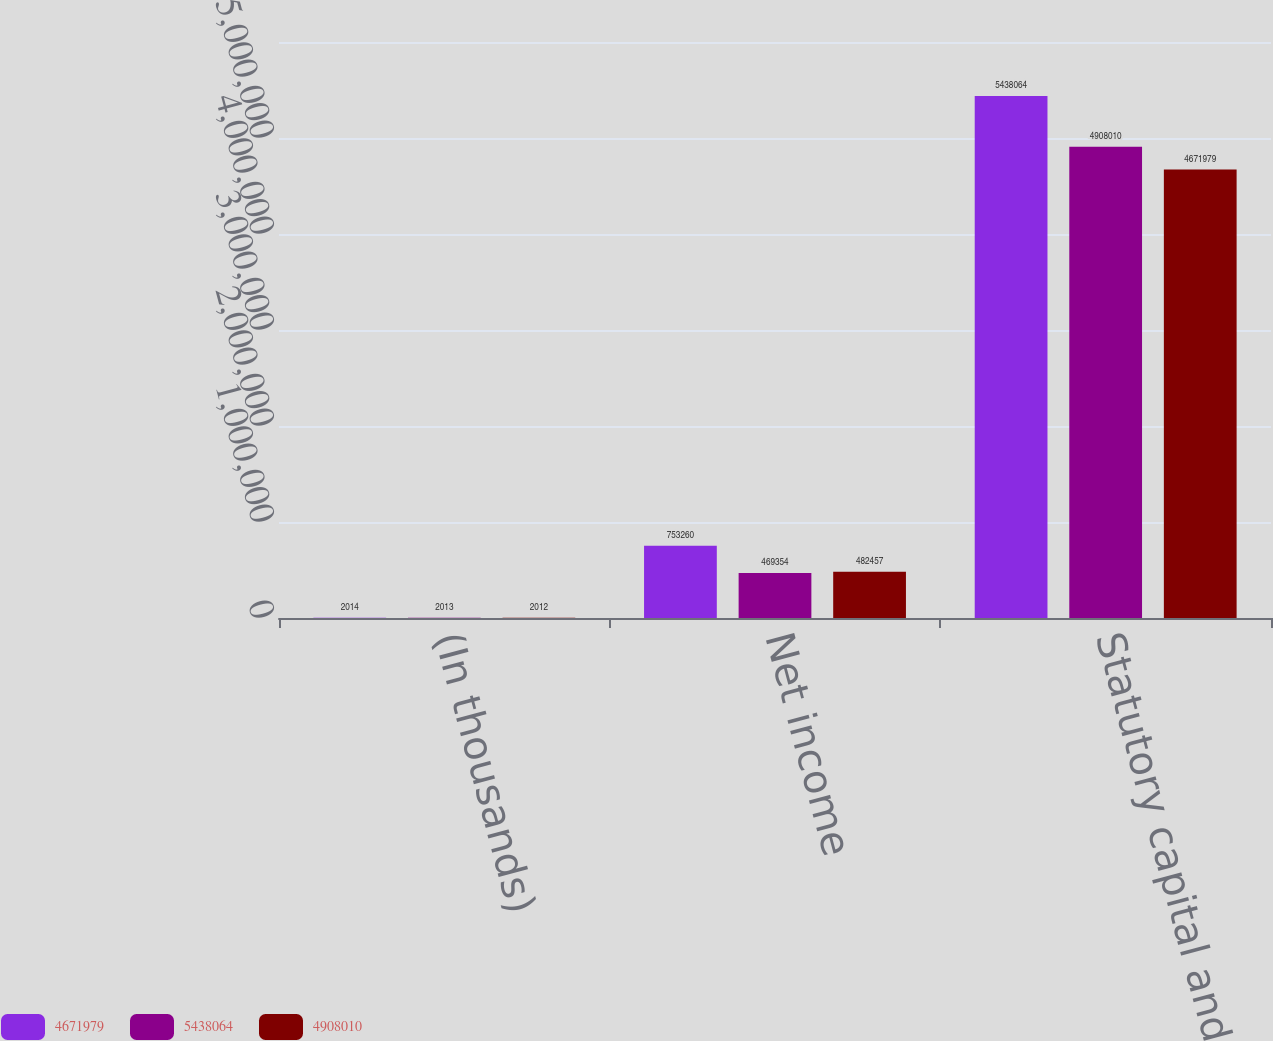Convert chart to OTSL. <chart><loc_0><loc_0><loc_500><loc_500><stacked_bar_chart><ecel><fcel>(In thousands)<fcel>Net income<fcel>Statutory capital and surplus<nl><fcel>4.67198e+06<fcel>2014<fcel>753260<fcel>5.43806e+06<nl><fcel>5.43806e+06<fcel>2013<fcel>469354<fcel>4.90801e+06<nl><fcel>4.90801e+06<fcel>2012<fcel>482457<fcel>4.67198e+06<nl></chart> 